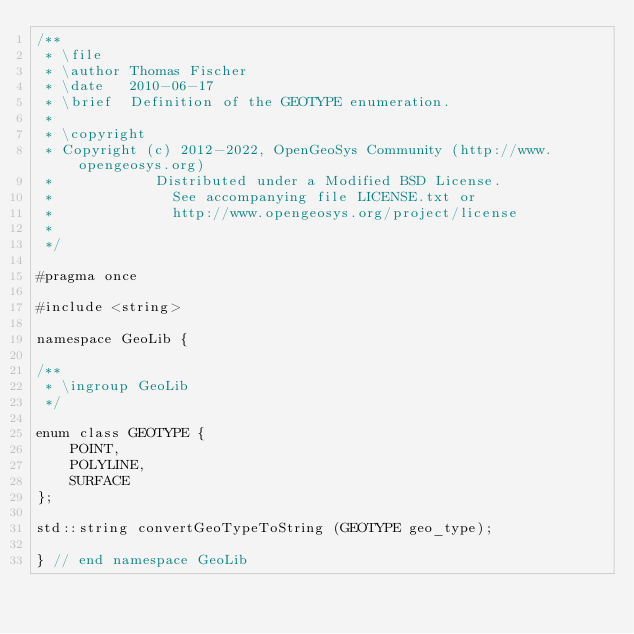Convert code to text. <code><loc_0><loc_0><loc_500><loc_500><_C_>/**
 * \file
 * \author Thomas Fischer
 * \date   2010-06-17
 * \brief  Definition of the GEOTYPE enumeration.
 *
 * \copyright
 * Copyright (c) 2012-2022, OpenGeoSys Community (http://www.opengeosys.org)
 *            Distributed under a Modified BSD License.
 *              See accompanying file LICENSE.txt or
 *              http://www.opengeosys.org/project/license
 *
 */

#pragma once

#include <string>

namespace GeoLib {

/**
 * \ingroup GeoLib
 */

enum class GEOTYPE {
    POINT,
    POLYLINE,
    SURFACE
};

std::string convertGeoTypeToString (GEOTYPE geo_type);

} // end namespace GeoLib
</code> 